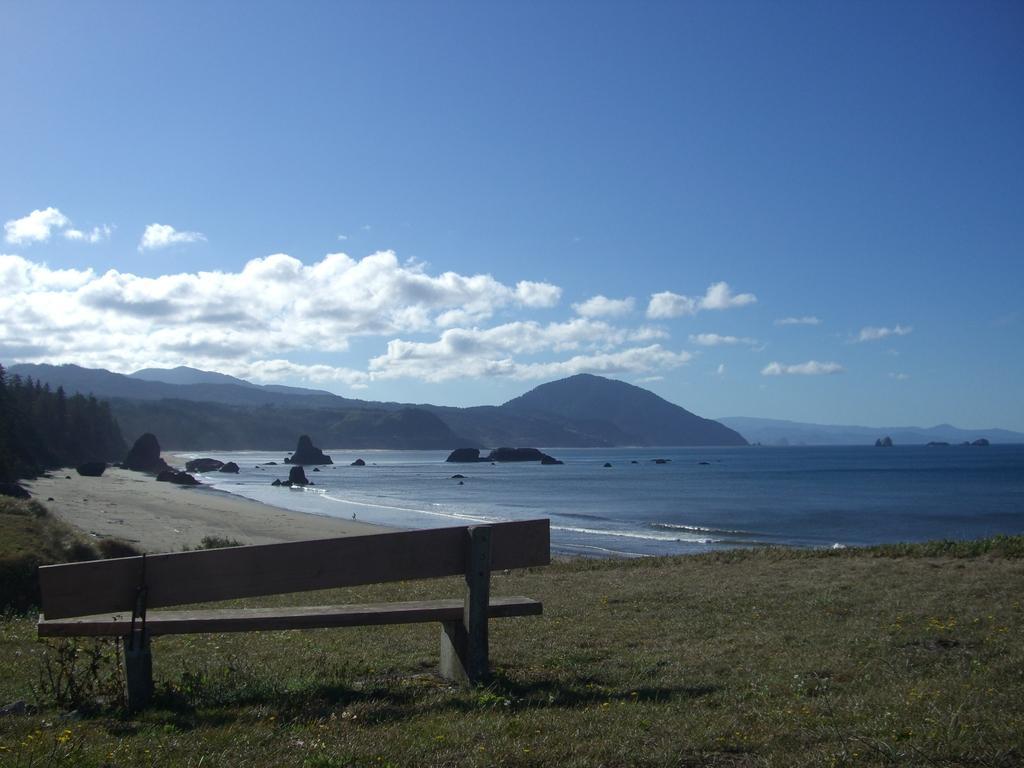How would you summarize this image in a sentence or two? In the image there is a sea and around the sea there are mountains, trees and there is a bench on the grass in the foreground. 